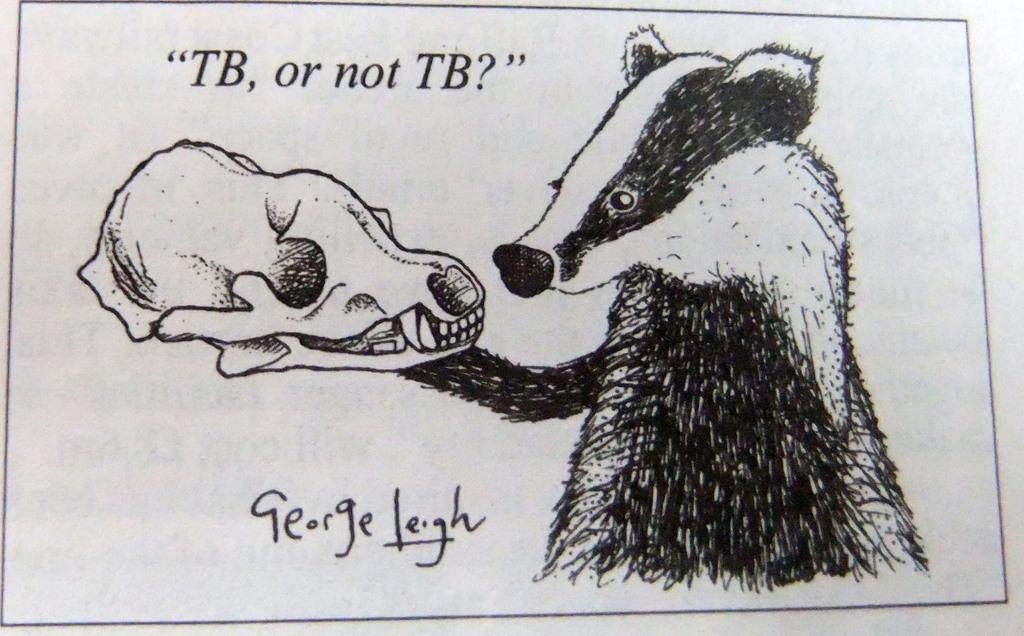Can you describe this image briefly? In this image I can see a painting of an animal, skeleton and text. It looks as if the image is taken from the book. 